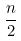Convert formula to latex. <formula><loc_0><loc_0><loc_500><loc_500>\frac { n } { 2 }</formula> 